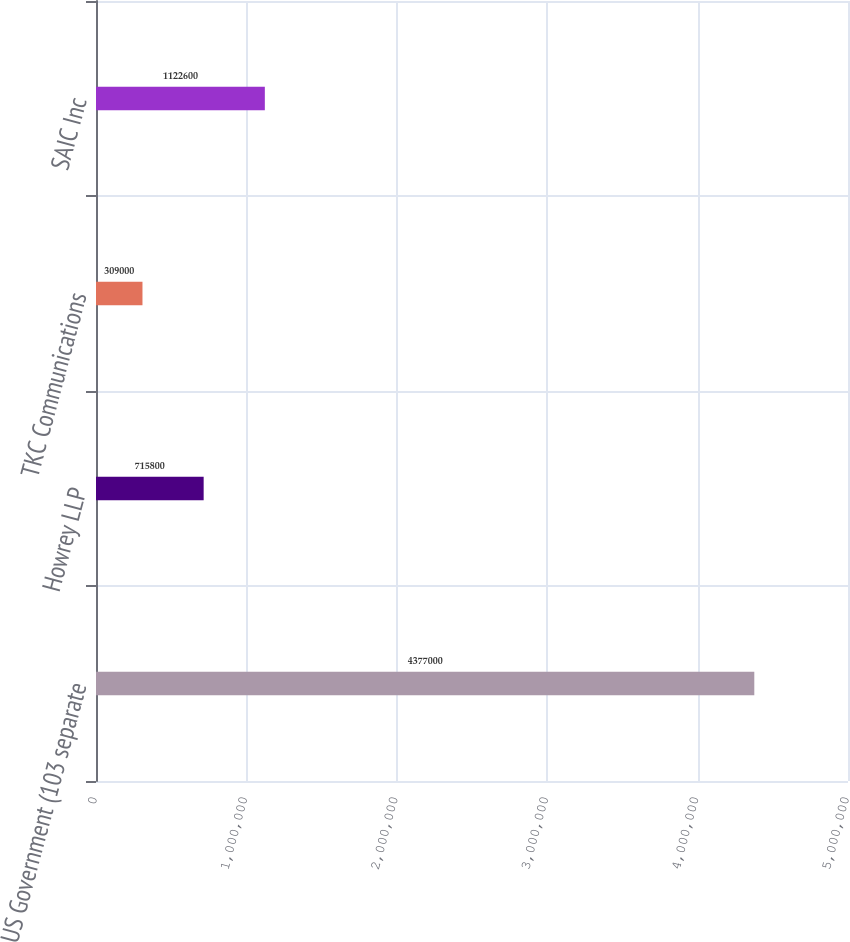Convert chart. <chart><loc_0><loc_0><loc_500><loc_500><bar_chart><fcel>US Government (103 separate<fcel>Howrey LLP<fcel>TKC Communications<fcel>SAIC Inc<nl><fcel>4.377e+06<fcel>715800<fcel>309000<fcel>1.1226e+06<nl></chart> 